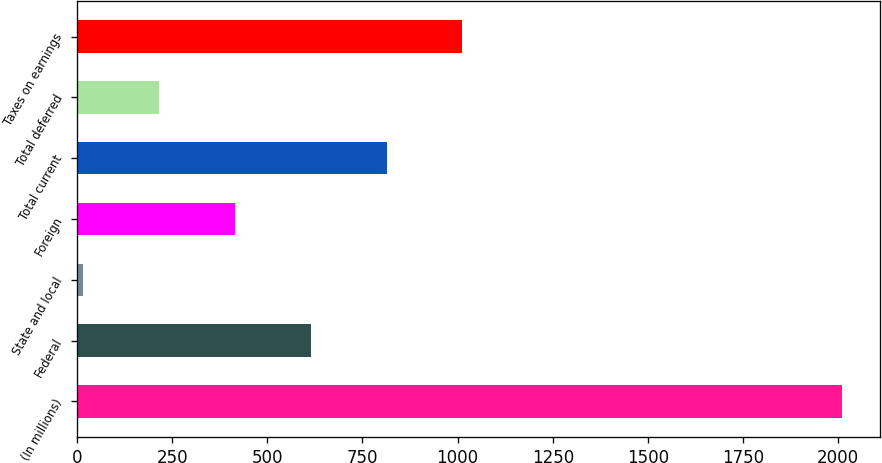<chart> <loc_0><loc_0><loc_500><loc_500><bar_chart><fcel>(In millions)<fcel>Federal<fcel>State and local<fcel>Foreign<fcel>Total current<fcel>Total deferred<fcel>Taxes on earnings<nl><fcel>2010<fcel>613.85<fcel>15.5<fcel>414.4<fcel>813.3<fcel>214.95<fcel>1012.75<nl></chart> 